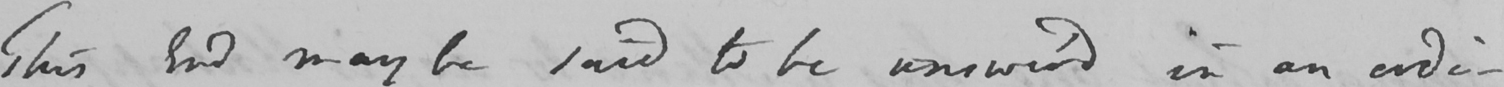What text is written in this handwritten line? This End may be said to be answer ' d in an ordi- 